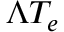Convert formula to latex. <formula><loc_0><loc_0><loc_500><loc_500>\Lambda T _ { e }</formula> 